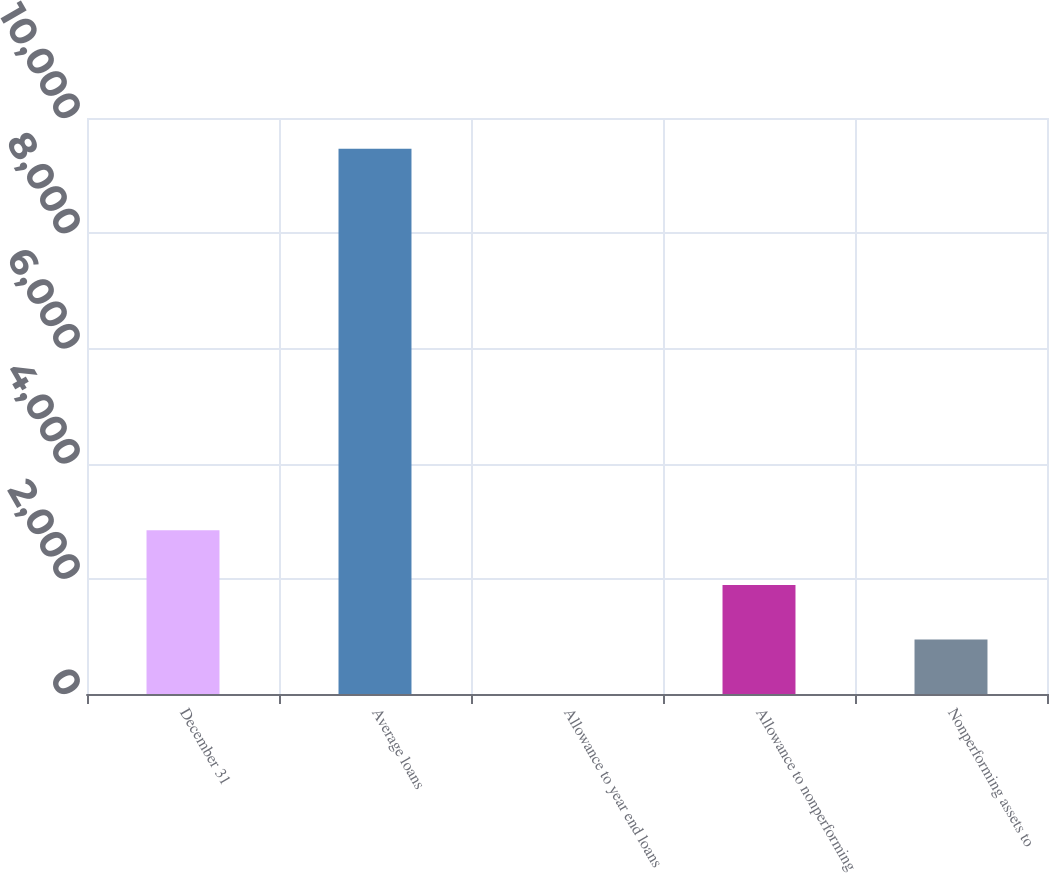Convert chart. <chart><loc_0><loc_0><loc_500><loc_500><bar_chart><fcel>December 31<fcel>Average loans<fcel>Allowance to year end loans<fcel>Allowance to nonperforming<fcel>Nonperforming assets to<nl><fcel>2840.8<fcel>9468<fcel>0.55<fcel>1894.05<fcel>947.3<nl></chart> 